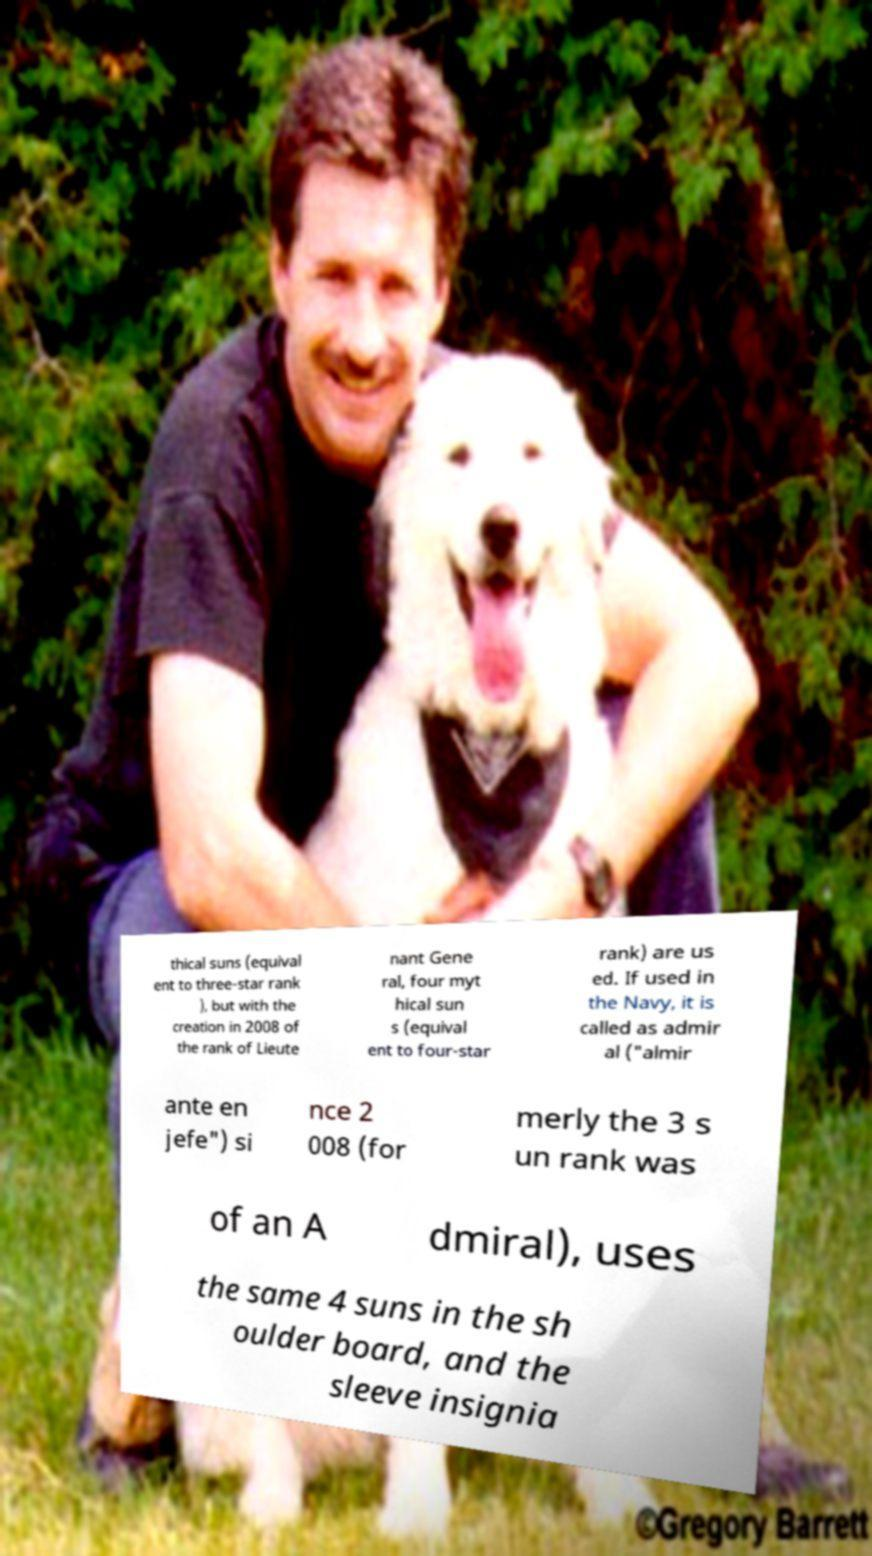Can you read and provide the text displayed in the image?This photo seems to have some interesting text. Can you extract and type it out for me? thical suns (equival ent to three-star rank ), but with the creation in 2008 of the rank of Lieute nant Gene ral, four myt hical sun s (equival ent to four-star rank) are us ed. If used in the Navy, it is called as admir al ("almir ante en jefe") si nce 2 008 (for merly the 3 s un rank was of an A dmiral), uses the same 4 suns in the sh oulder board, and the sleeve insignia 